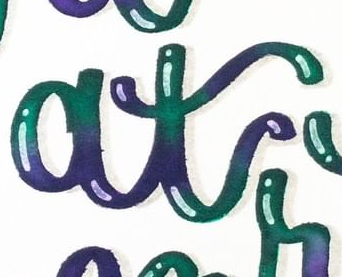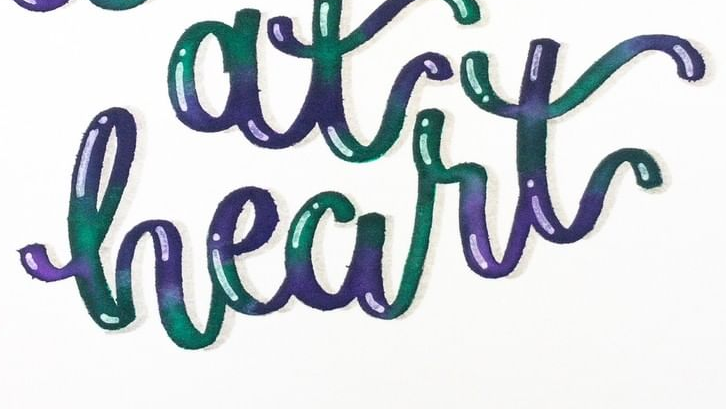What text appears in these images from left to right, separated by a semicolon? at; heart 